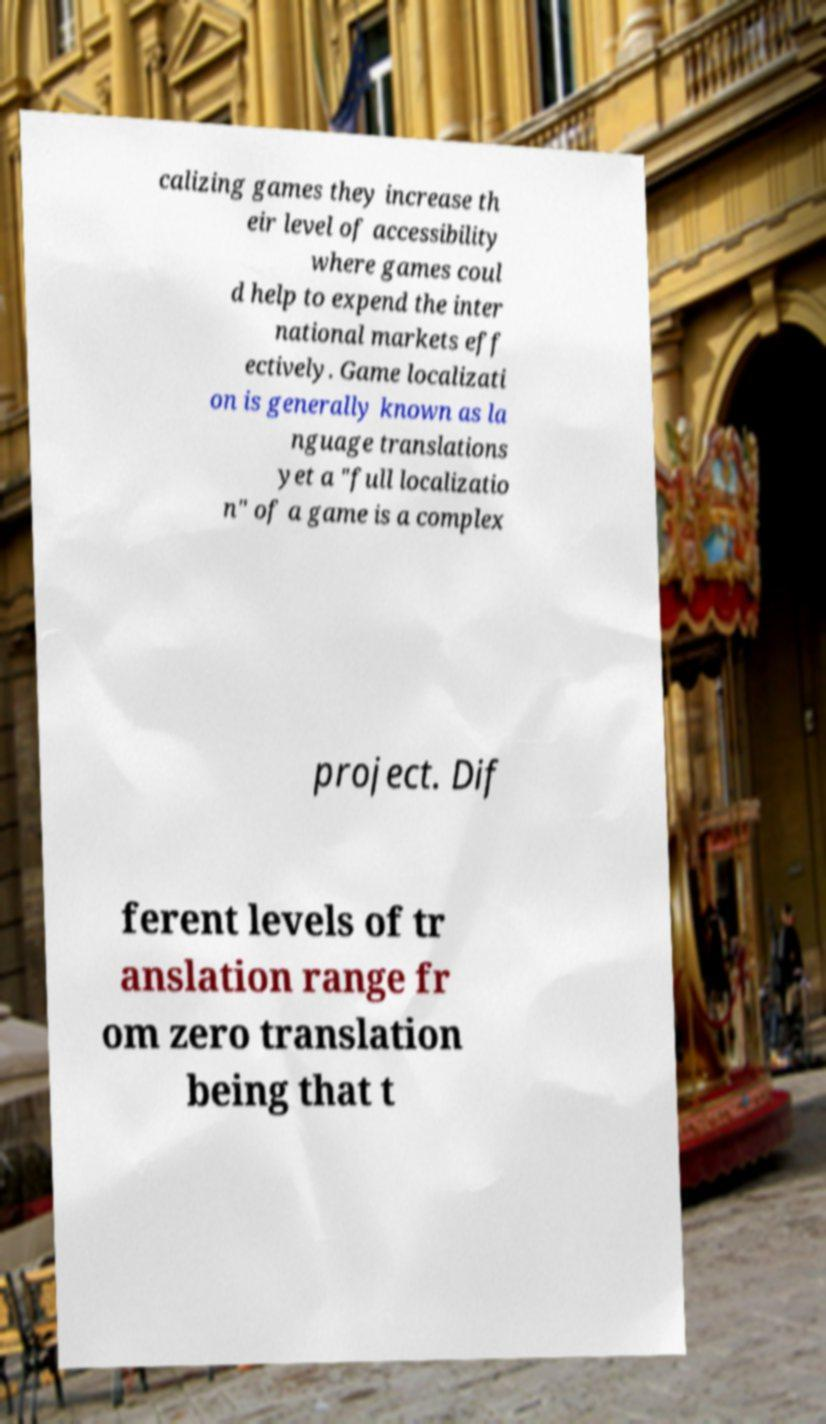There's text embedded in this image that I need extracted. Can you transcribe it verbatim? calizing games they increase th eir level of accessibility where games coul d help to expend the inter national markets eff ectively. Game localizati on is generally known as la nguage translations yet a "full localizatio n" of a game is a complex project. Dif ferent levels of tr anslation range fr om zero translation being that t 